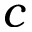<formula> <loc_0><loc_0><loc_500><loc_500>c</formula> 